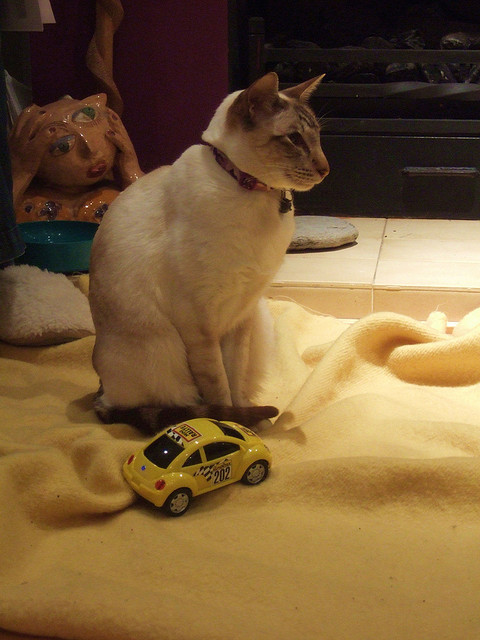Identify the text contained in this image. 202 